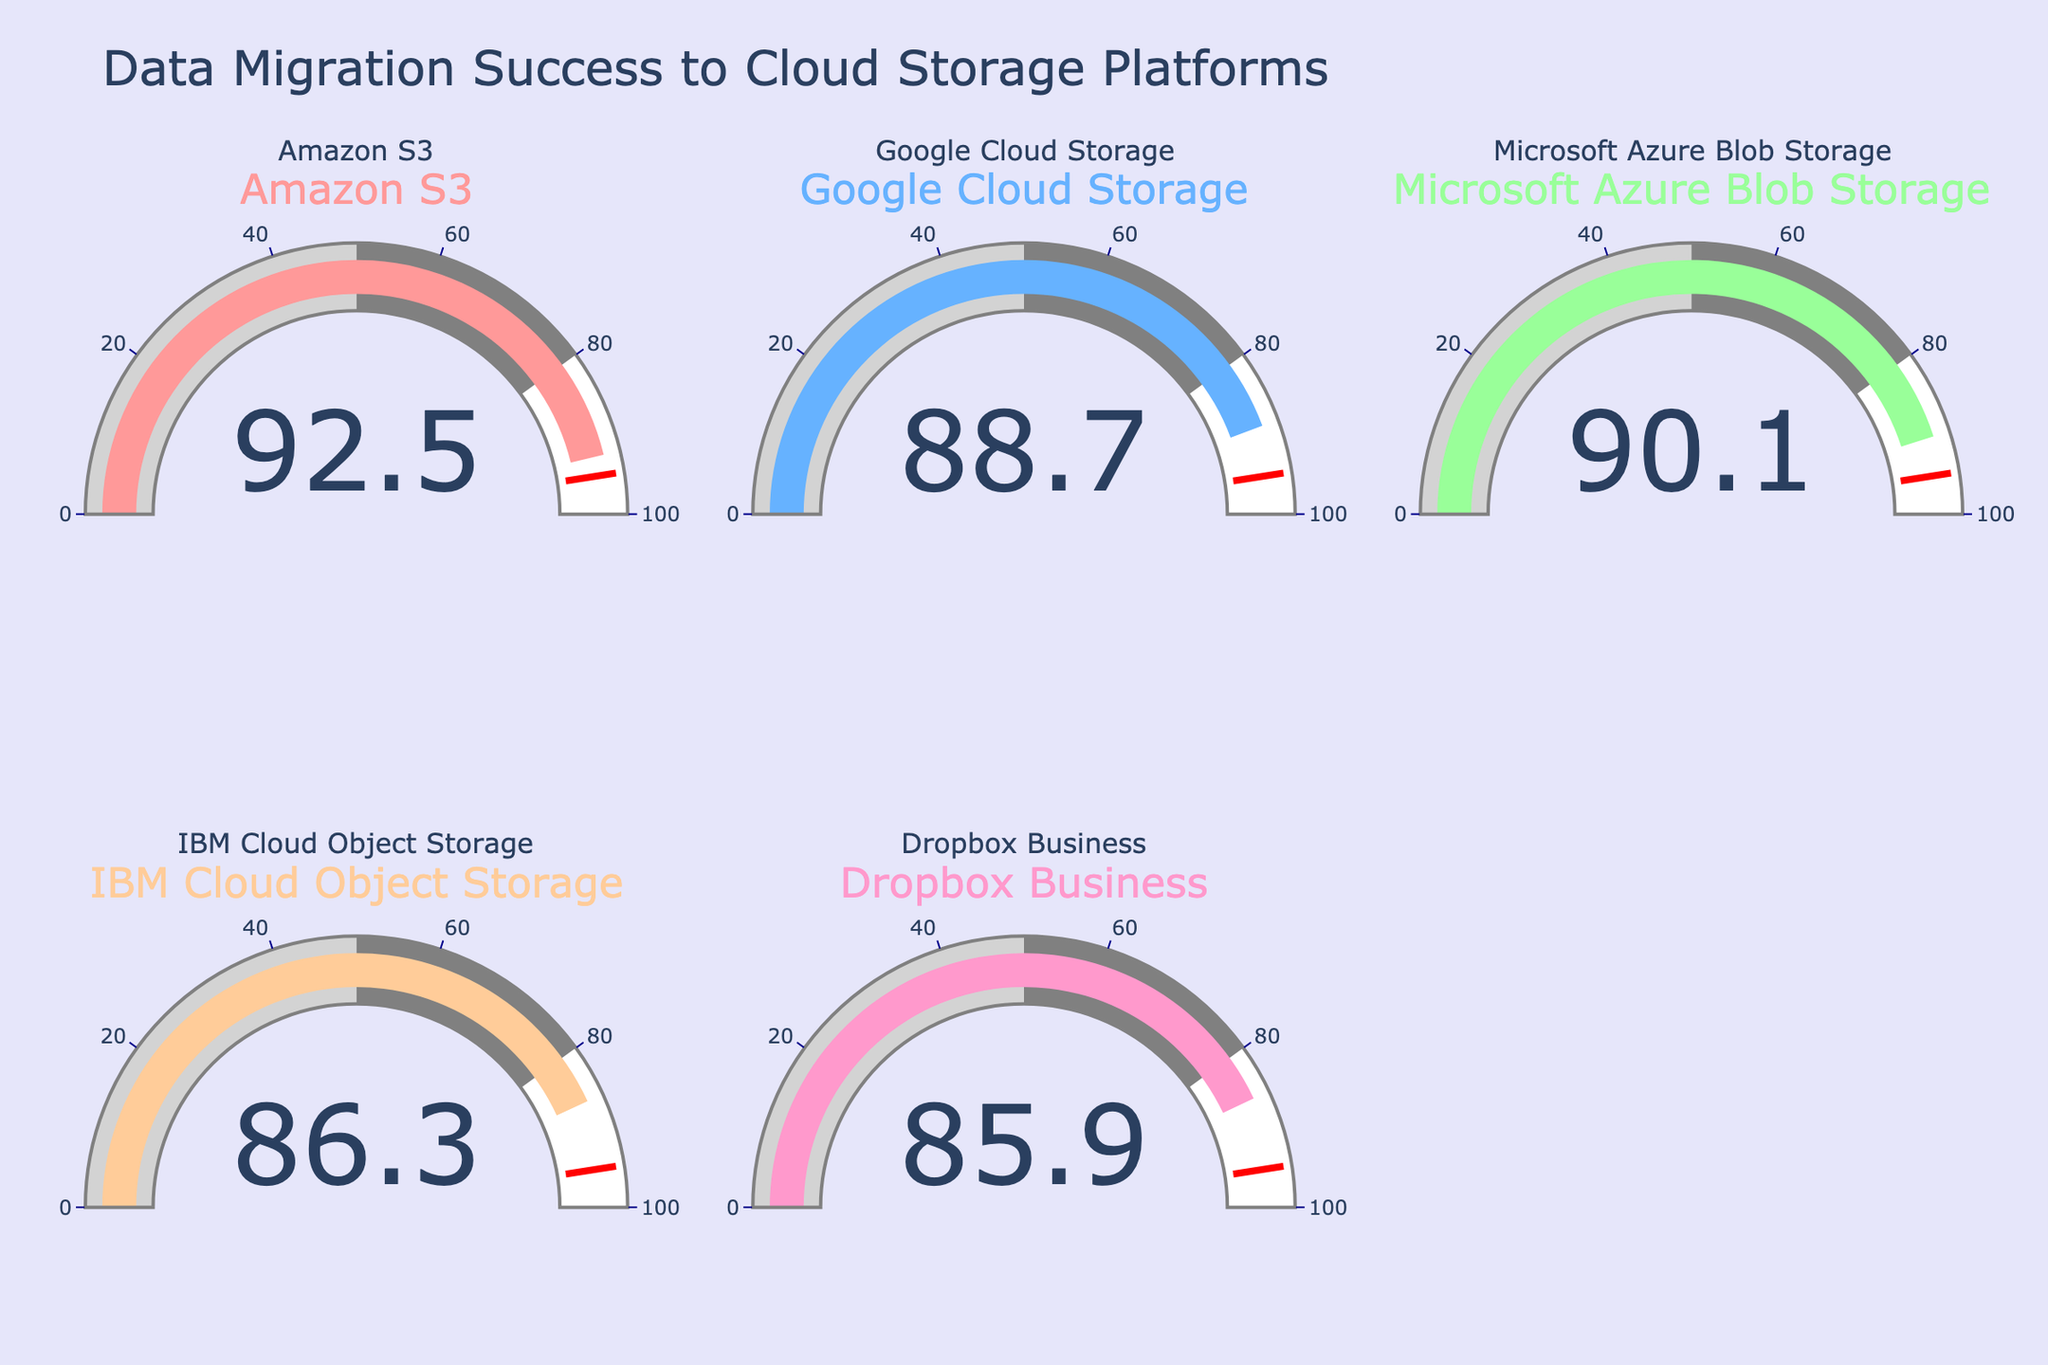What's the percentage of data successfully migrated to Amazon S3? The gauge for Amazon S3 shows a value. Look for the number in this gauge to find the percentage.
Answer: 92.5% Which cloud storage platform has the lowest percentage of successful data migration? Compare the values of all gauges and identify the one with the smallest value to determine the platform with the lowest success rate.
Answer: Dropbox Business What is the total percentage of data successfully migrated to Amazon S3 and Microsoft Azure Blob Storage combined? Sum the percentages of the gauges for Amazon S3 and Microsoft Azure Blob Storage: 92.5 + 90.1 = 182.6
Answer: 182.6% How does the success rate of Google Cloud Storage compare to IBM Cloud Object Storage? Compare the percentages from the gauges of Google Cloud Storage (88.7) and IBM Cloud Object Storage (86.3) to determine which is higher.
Answer: Google Cloud Storage has a higher rate By how much does Amazon S3's success rate exceed that of Dropbox Business? Subtract the percentage of Dropbox Business from Amazon S3: 92.5 - 85.9 = 6.6
Answer: 6.6 What is the average percentage of successful data migration across all platforms? Calculate the average by summing all percentages and dividing by the number of platforms: (92.5 + 88.7 + 90.1 + 86.3 + 85.9) / 5 = 88.7
Answer: 88.7 How many platforms have a migration success rate above 90%? Count the gauges with values above 90%. Amazon S3 (92.5) and Microsoft Azure Blob Storage (90.1) are the only ones above 90%.
Answer: 2 Which platform is closest to the threshold value of 95%? Compare each gauge value to 95% and determine which is closest. Amazon S3 is at 92.5%, closest among all.
Answer: Amazon S3 What's the difference between the highest and lowest migration success rates? Find the difference between the maximum and minimum percentages: 92.5 (Amazon S3) - 85.9 (Dropbox Business) = 6.6
Answer: 6.6 Which two platforms have the smallest difference in migration success rates? Calculate the differences between each pair of platforms and find the smallest difference: Google Cloud Storage (88.7) and IBM Cloud Object Storage (86.3) have a difference of 2.4
Answer: Google Cloud Storage and IBM Cloud Object Storage 